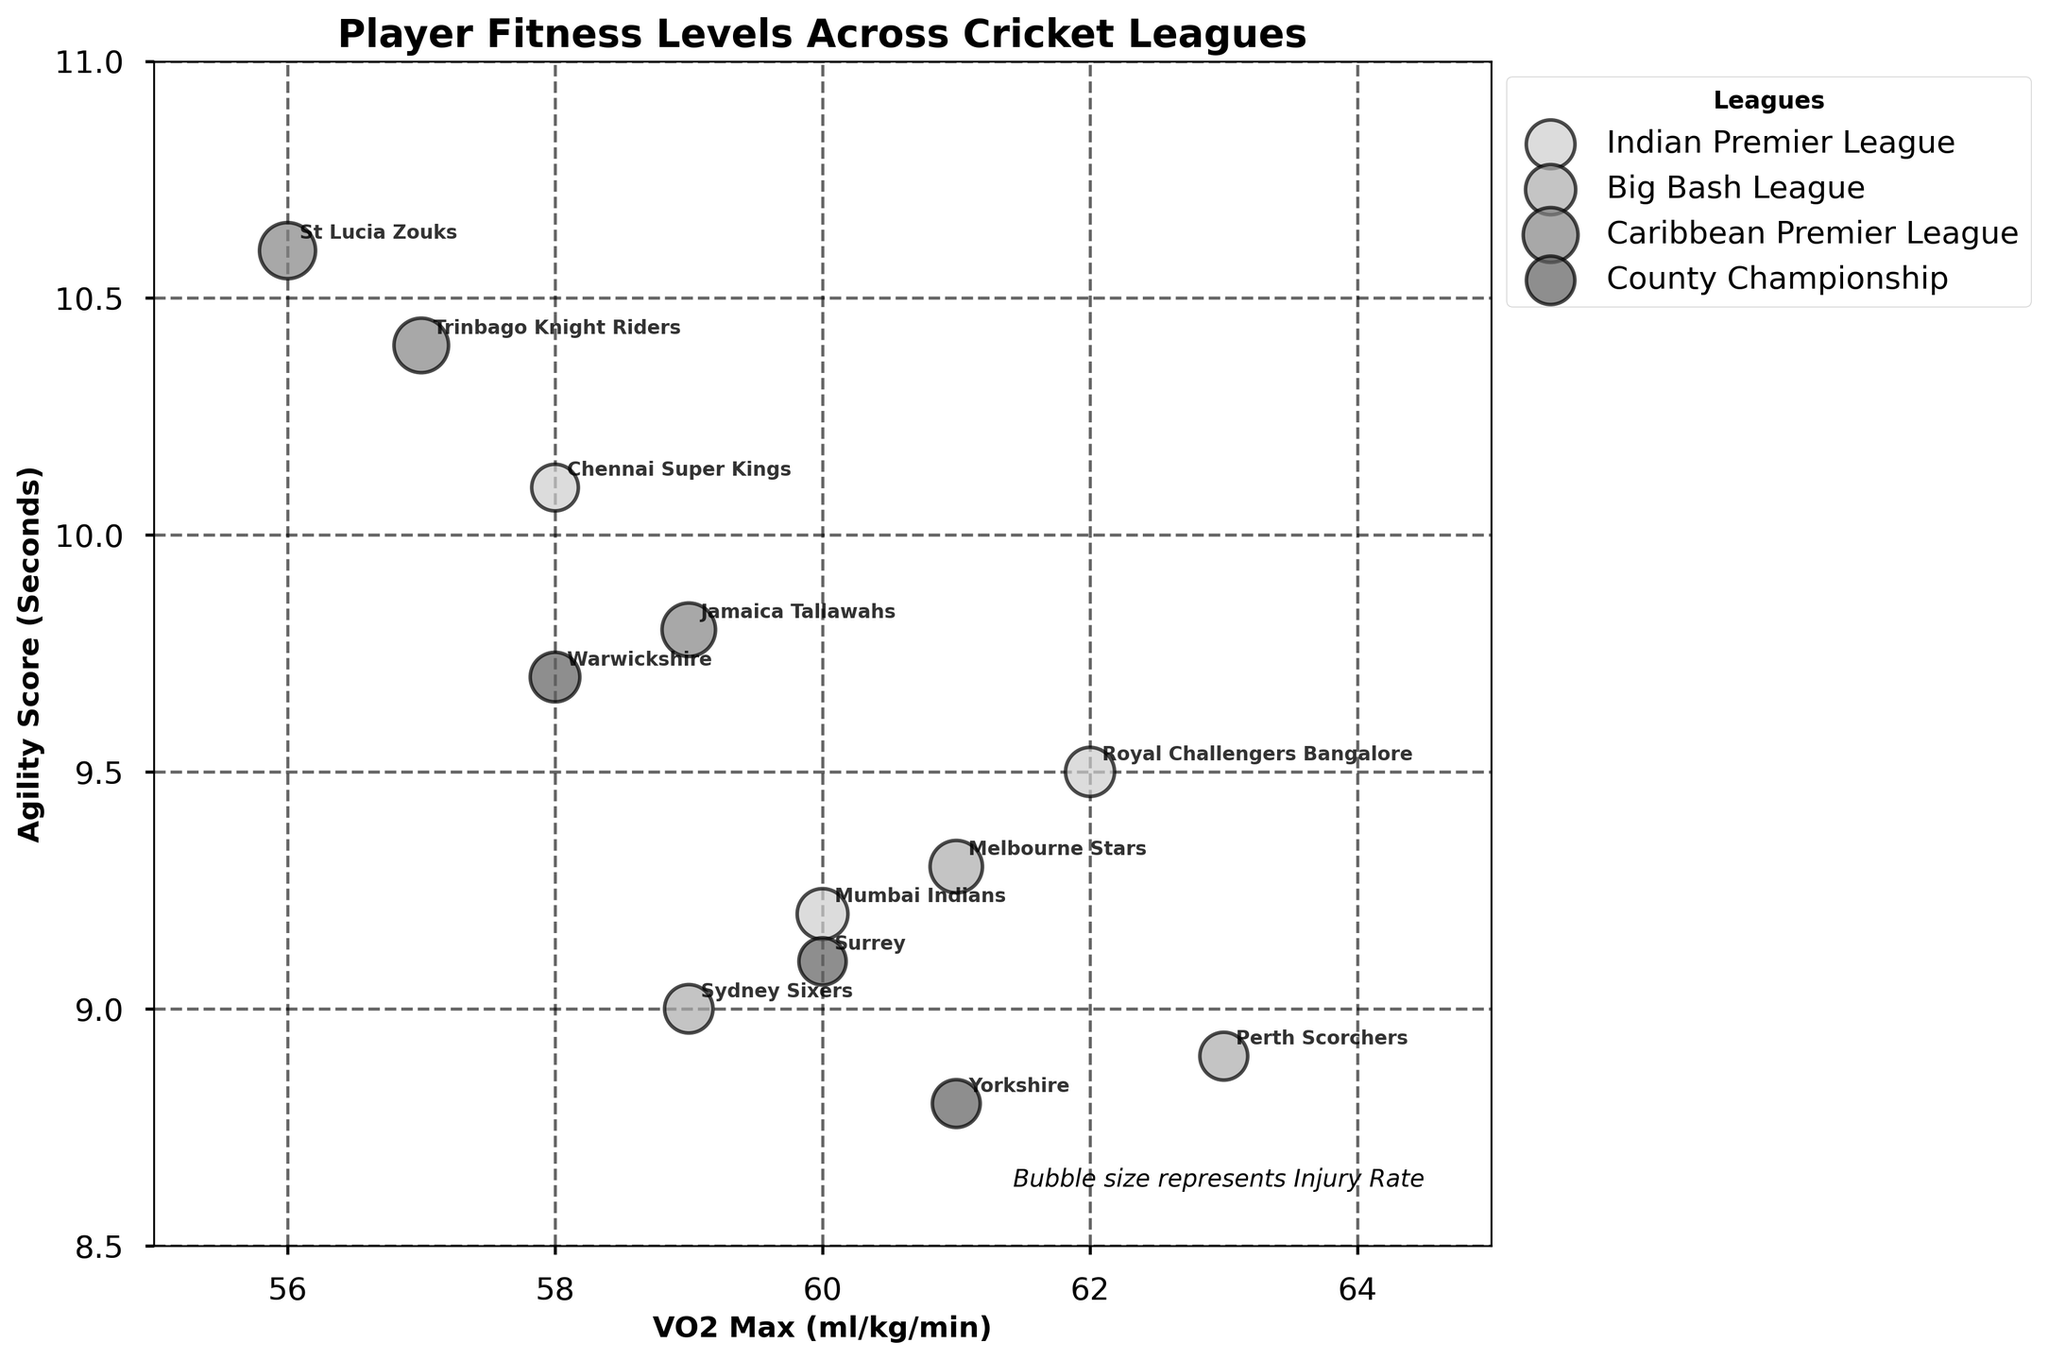What is the title of the chart? The title of the chart is displayed at the top in bold text.
Answer: Player Fitness Levels Across Cricket Leagues What does the size of the bubbles represent in this chart? The text at the bottom right of the chart informs that the bubble size represents the injury rate.
Answer: Injury Rate Which team has the highest VO2 Max? The VO2 Max values can be read along the x-axis. Positioned at the highest point on the VO2 Max scale is the team Perth Scorchers.
Answer: Perth Scorchers Which league has the most teams with higher agility scores (lower numbers)? To determine this, look at the spread of teams along the y-axis. The County Championship and Big Bash League have many points clustered lower in the agility score scale.
Answer: County Championship and Big Bash League Which team in the Indian Premier League has the lowest injury rate? By identifying the size of the bubbles corresponding to the Indian Premier League and comparing their sizes, Chennai Super Kings have the smallest bubble indicating the lowest injury rate.
Answer: Chennai Super Kings What is the difference in VO2 Max between Sydney Sixers and Jamaica Tallawahs? Sydney Sixers has a VO2 Max of 59 ml/kg/min and Jamaica Tallawahs has 59 ml/kg/min. Subtract the latter from the former to find the difference: 59 - 59 = 0 ml/kg/min.
Answer: 0 ml/kg/min Which league has the team with the best agility score? The lowest agility score is the best. The Perth Scorchers in the Big Bash League has the lowest agility score of 8.9 seconds.
Answer: Big Bash League How does the agility score of Melbourne Stars compare to that of Trinbago Knight Riders? Melbourne Stars have an agility score of 9.3 seconds while Trinbago Knight Riders have 10.4 seconds. Comparing the two shows that Melbourne Stars have a lower (better) agility score.
Answer: Melbourne Stars have a lower agility score What is the average VO2 Max of the teams in the Caribbean Premier League? The teams in the Caribbean Premier League have VO2 Max values of 57, 56, and 59 ml/kg/min. The average is calculated as (57 + 56 + 59) / 3 = 57.33 ml/kg/min.
Answer: 57.33 ml/kg/min Which team has the highest injury rate and in which league do they play? The bubble corresponding to the highest injury rate would be the largest. The largest bubble belongs to the team St Lucia Zouks from the Caribbean Premier League.
Answer: St Lucia Zouks, Caribbean Premier League 